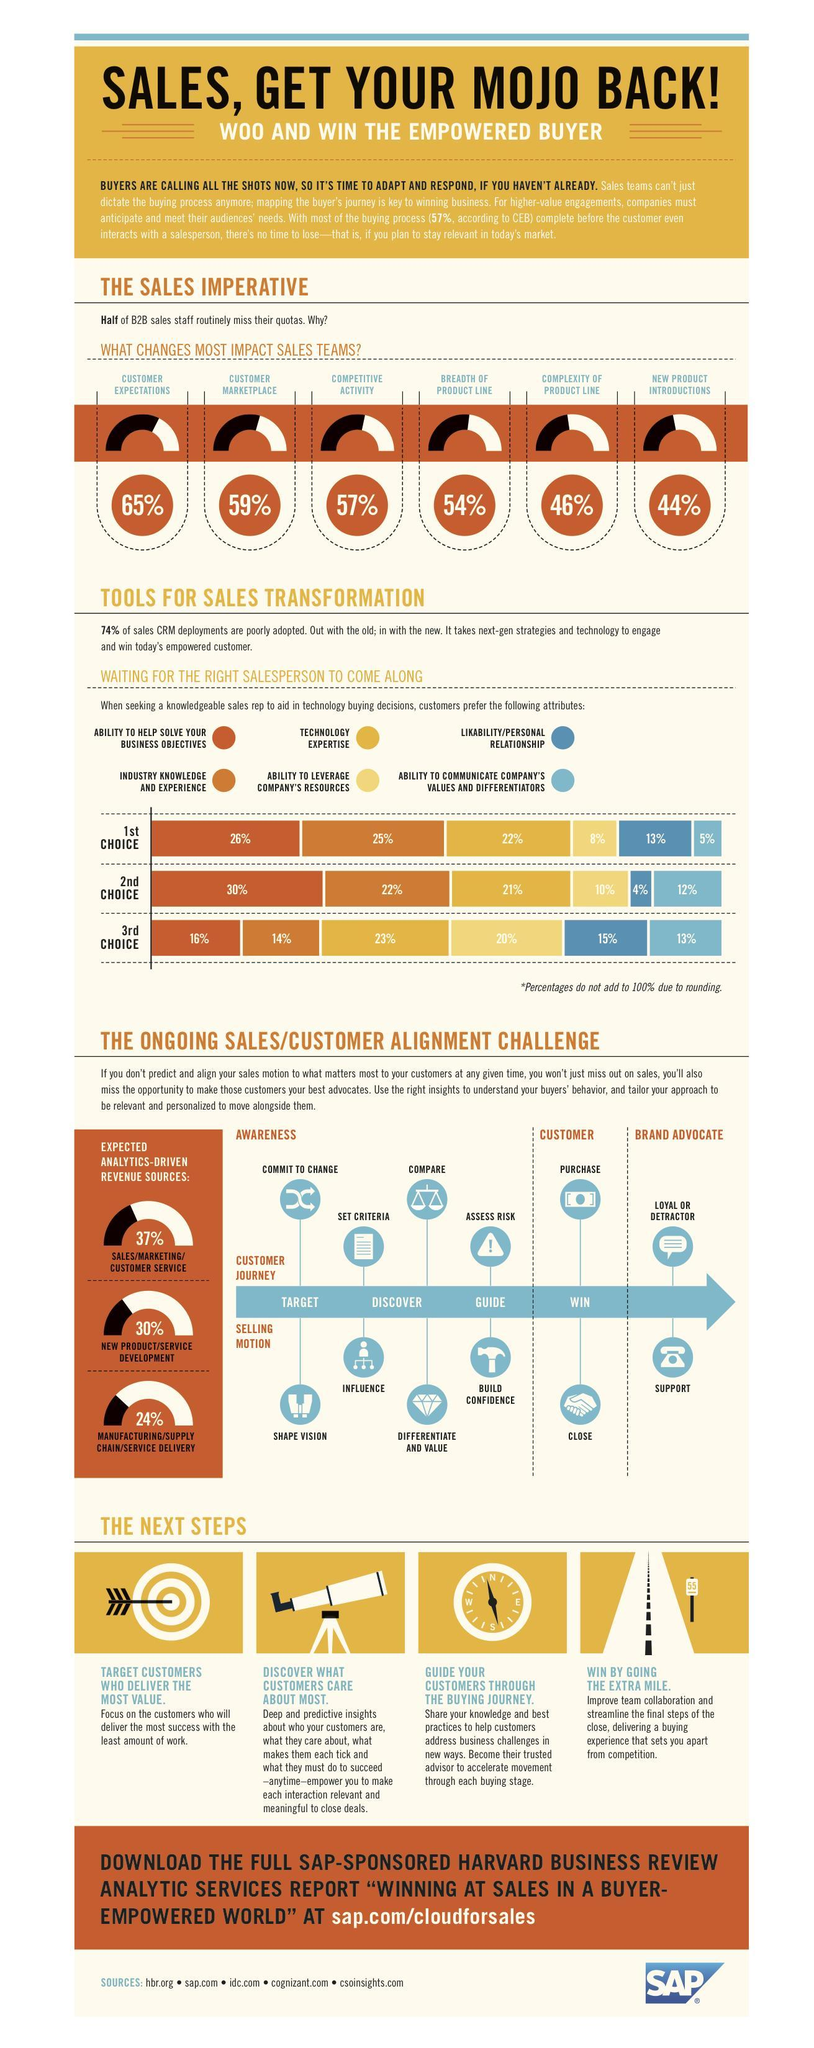What percentage of businesses seek a sales rep who has technology expertise as their first choice?
Answer the question with a short phrase. 22% What percentage of businesses seek sales rep with industry knowledge and experience as their third choice? 14% What is the next step provided by the business in Sales motion after a customer purchases the product or service? Support What percentage of businesses seek sales rep with likable personality as their second choice? 4% What is the next step taken by customers after a business helps them differentiate and value their product or service? Assess Risk Which steps indicate a win-win situation for both the customer and business? Purchase, Close What are the steps a business should concentrate on during the discover phase of the selling motion? Influence, Differentiate And Value What is the total percentage of businesses seeking sales rep with an ability to express company's values? 30% What percentage of  competitive activity impact the sales, 65%, 59%, or 57%? 57% 